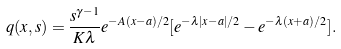<formula> <loc_0><loc_0><loc_500><loc_500>q ( x , s ) = \frac { s ^ { \gamma - 1 } } { K \lambda } e ^ { - A ( x - a ) / 2 } [ e ^ { - \lambda | x - a | / 2 } - e ^ { - \lambda ( x + a ) / 2 } ] .</formula> 